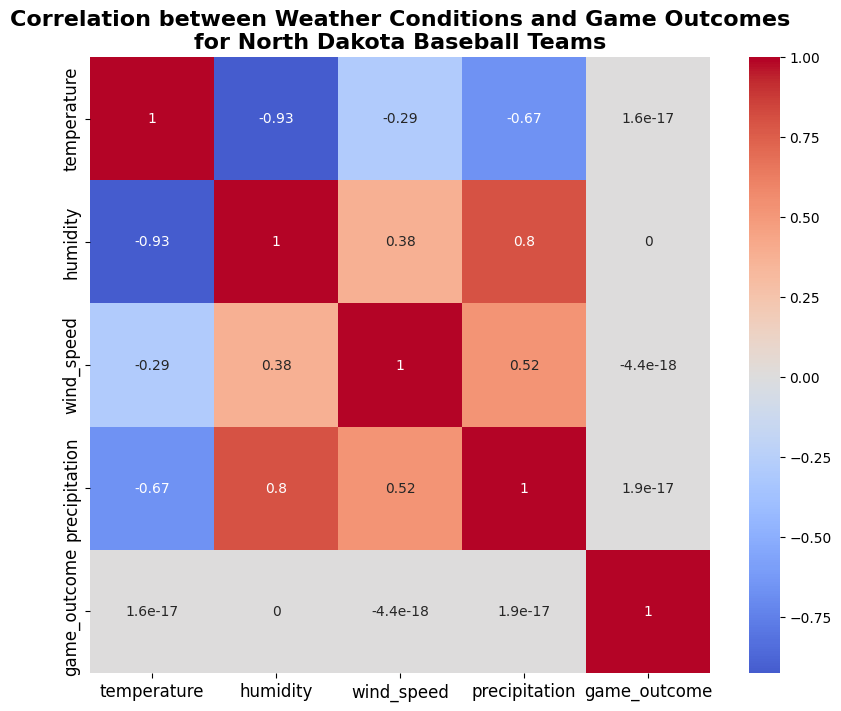How strongly does temperature correlate with game outcomes? The heatmap shows a correlation coefficient between temperature and game outcomes. Identify the color and annotated value at the intersection of the temperature row and game outcome column.
Answer: 0.15 Which two weather conditions have the strongest correlation with each other? Look for the pair of weather conditions that have the highest positive or negative correlation value. Check the annotated values and colors in the heatmap.
Answer: Temperature and humidity (-0.74) Is the correlation between wind speed and game outcome stronger than that between precipitation and game outcome? Compare the correlation coefficients between wind speed and game outcome with that between precipitation and game outcome by checking their respective annotated values.
Answer: Yes What is the visual color representation of the correlation between temperature and humidity? Identify the color mapped to the correlation value between temperature and humidity in the heatmap.
Answer: Dark blue How does the correlation between precipitation and game outcomes compare to the correlation between humidity and game outcomes? Compare the annotated values of the correlation coefficients between precipitation and game outcomes and between humidity and game outcomes in the heatmap.
Answer: Precipitation correlates less strongly (0.00) than humidity (-0.24) with game outcomes What is the correlation value between wind speed and game outcome, and what does this suggest? Find the annotated number that indicates the correlation value between wind speed and game outcome in the heatmap and interpret it.
Answer: 0.0 Do higher temperatures tend to result in more wins or losses for the teams? Check the correlation value between temperature and game outcomes. A positive correlation means higher temperatures are associated with wins, and a negative correlation means the opposite.
Answer: More wins Which correlation is visually shown to be the least significant? Identify the correlation coefficient closest to zero by looking at the closest-to-white colors in the heatmap.
Answer: Wind speed and game outcome (0.0) Does higher humidity seem to favor one type of game outcome over the other? Look at the correlation coefficient between humidity and game outcomes. Determine if the correlation value indicates a positive or negative relationship.
Answer: Negative, indicating higher humidity is associated with losses 